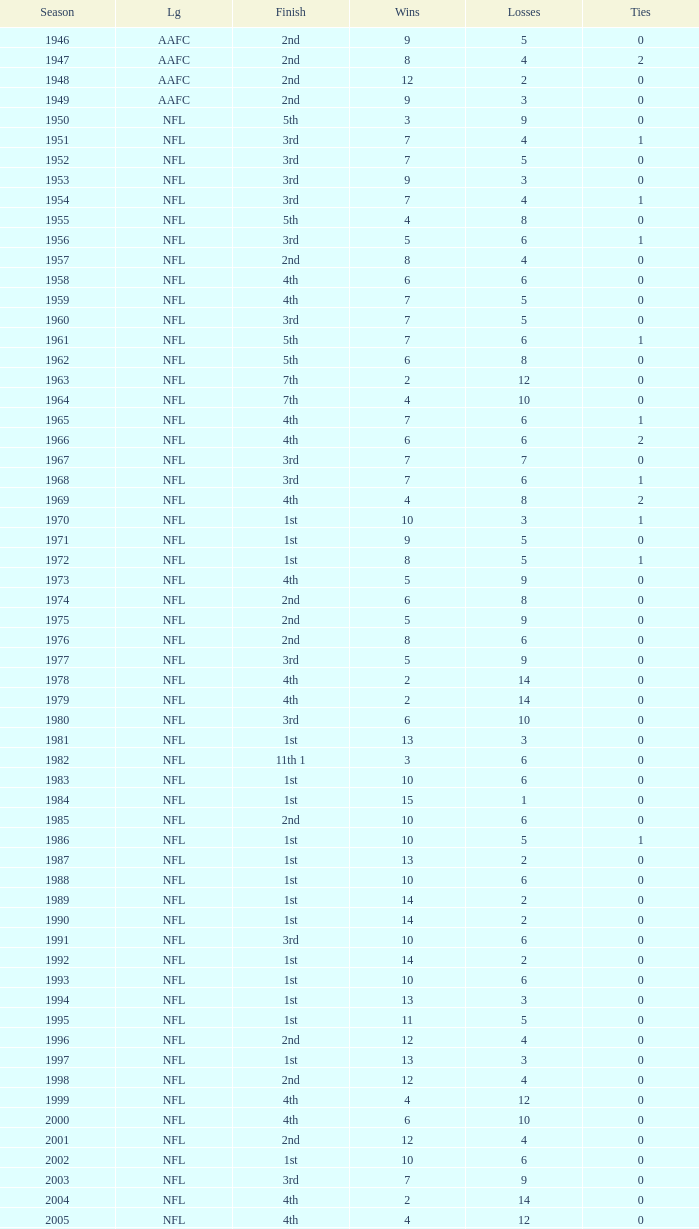What is the lowest number of ties in the NFL, with less than 2 losses and less than 15 wins? None. 